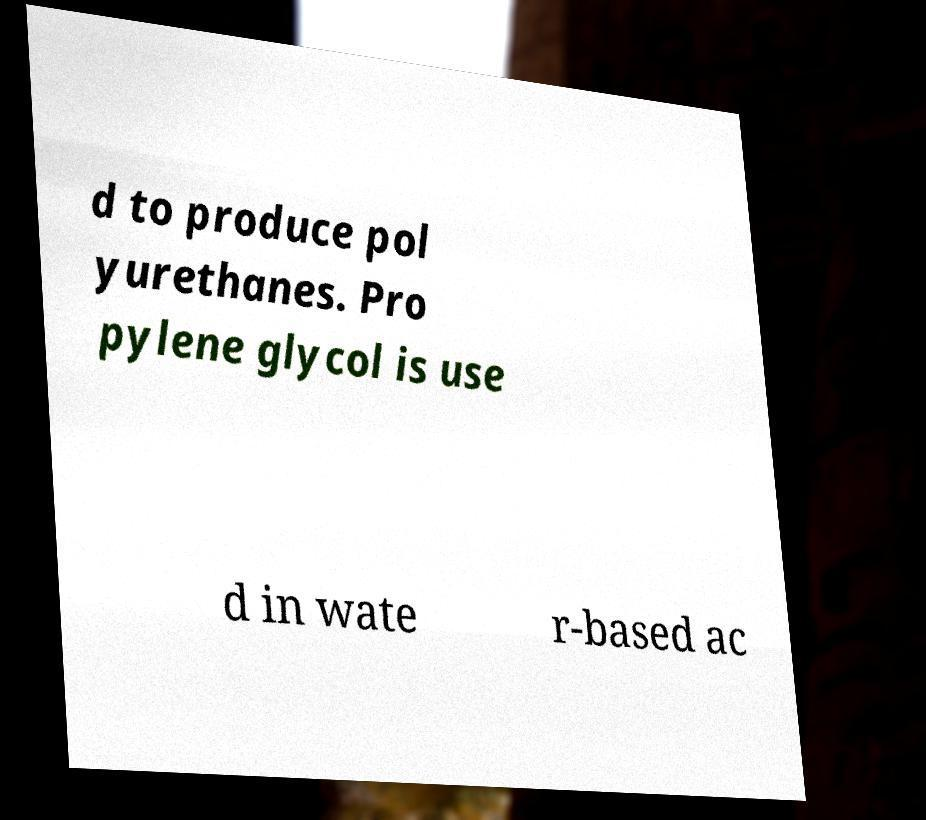Could you assist in decoding the text presented in this image and type it out clearly? d to produce pol yurethanes. Pro pylene glycol is use d in wate r-based ac 